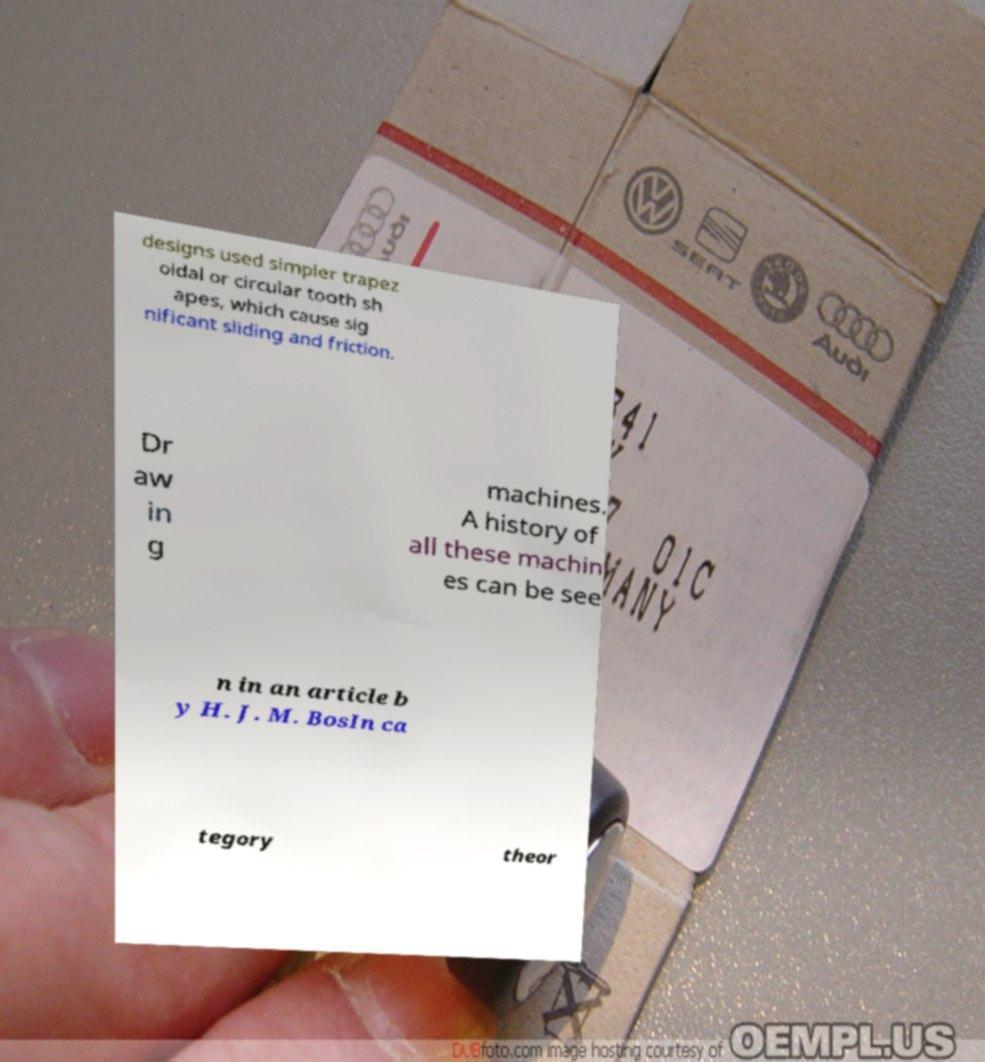There's text embedded in this image that I need extracted. Can you transcribe it verbatim? designs used simpler trapez oidal or circular tooth sh apes, which cause sig nificant sliding and friction. Dr aw in g machines. A history of all these machin es can be see n in an article b y H. J. M. BosIn ca tegory theor 